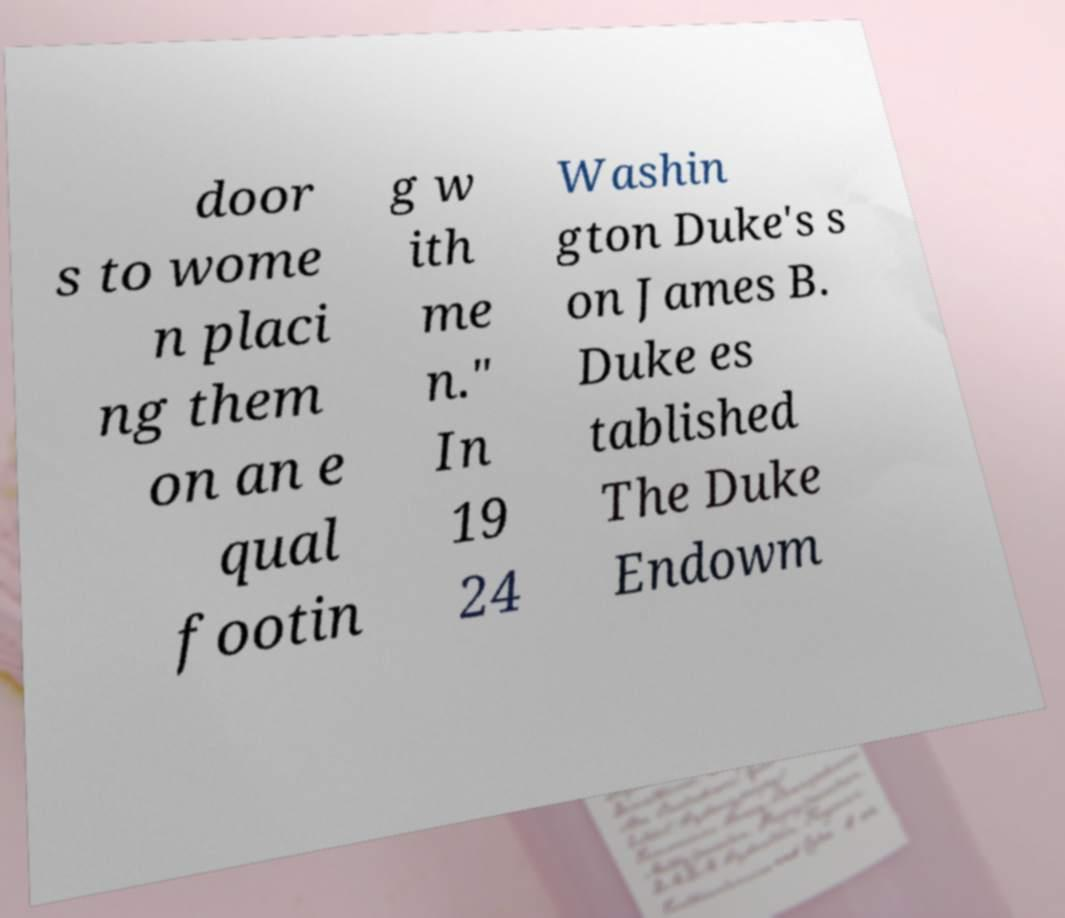There's text embedded in this image that I need extracted. Can you transcribe it verbatim? door s to wome n placi ng them on an e qual footin g w ith me n." In 19 24 Washin gton Duke's s on James B. Duke es tablished The Duke Endowm 